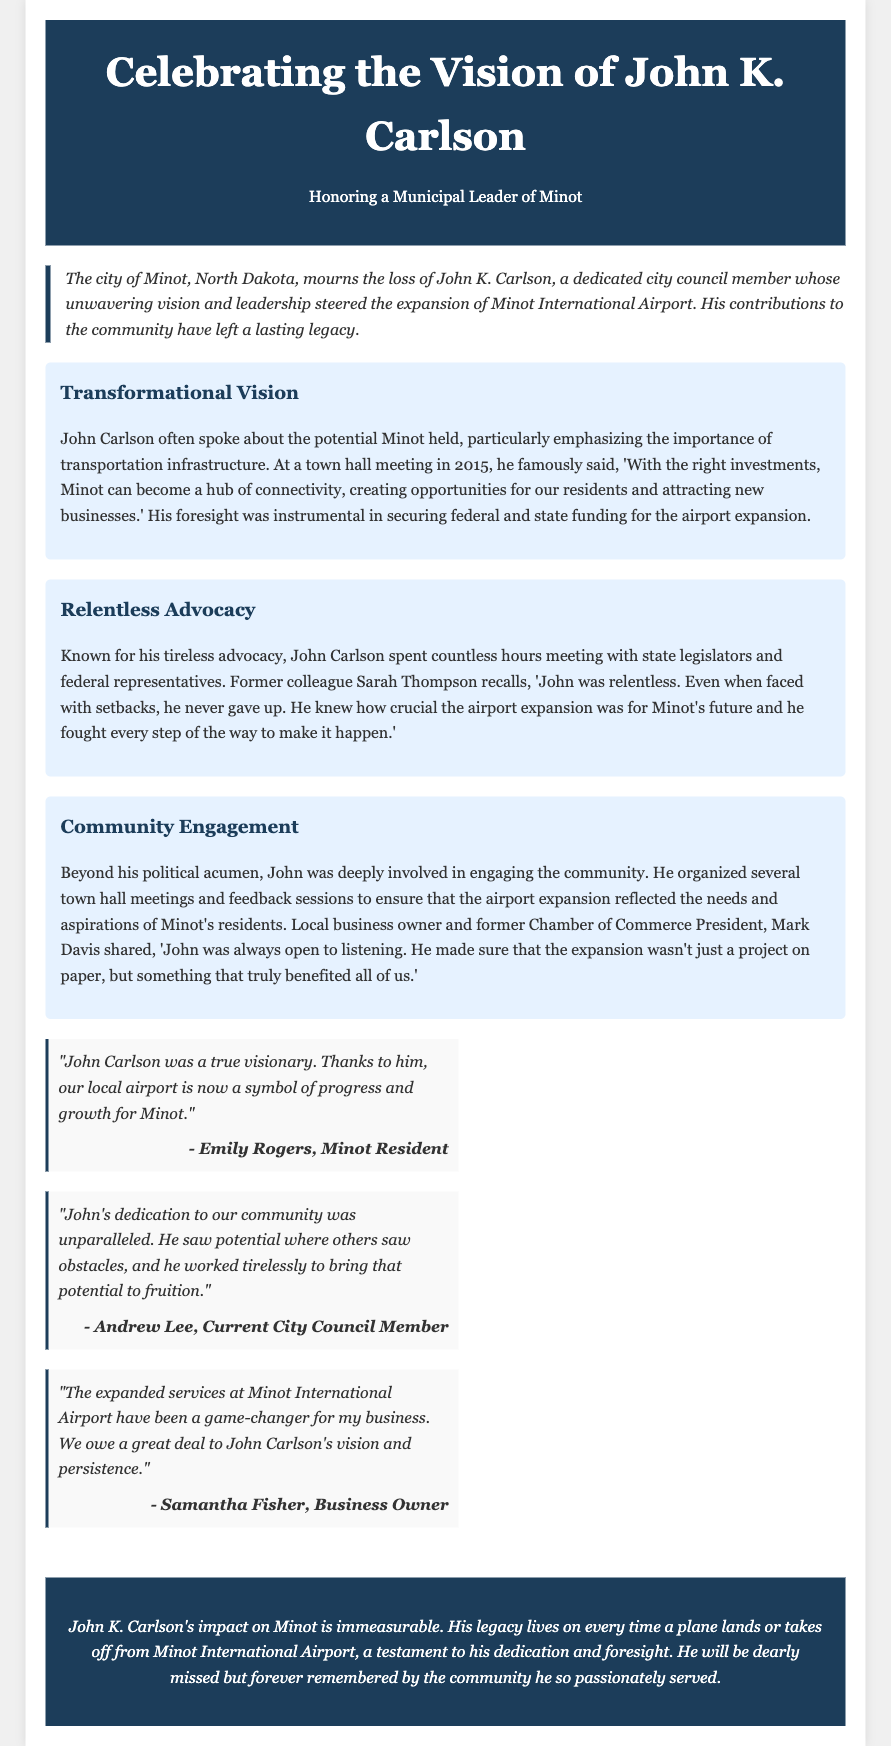what was John K. Carlson's role in the community? The document states that John K. Carlson was a dedicated city council member.
Answer: city council member what did John Carlson advocate for? The document mentions that he played a key role in advocating for the expansion of Minot International Airport.
Answer: expansion of Minot International Airport in what year did John Carlson speak about Minot's potential at a town hall meeting? The document specifies that he spoke at a town hall meeting in 2015.
Answer: 2015 who remembers John Carlson's relentless advocacy? The document cites former colleague Sarah Thompson as recalling his tireless advocacy.
Answer: Sarah Thompson how did John Carlson ensure community engagement? He organized several town hall meetings and feedback sessions.
Answer: town hall meetings and feedback sessions what did Emily Rogers say about John Carlson? Emily Rogers said that he was a true visionary.
Answer: true visionary who is quoted saying the airport expansion was a game-changer for their business? The document includes a quote from Samantha Fisher regarding the airport expansion.
Answer: Samantha Fisher what color scheme is used for the header of the tribute? The header has a background color of #1c3d5a, which is a shade of dark blue.
Answer: dark blue what type of document is this? The document is an obituary.
Answer: obituary 